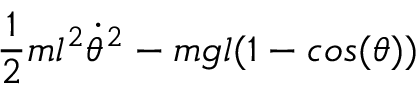Convert formula to latex. <formula><loc_0><loc_0><loc_500><loc_500>\frac { 1 } { 2 } m l ^ { 2 } \dot { \theta } ^ { 2 } - m g l ( 1 - \cos ( \theta ) )</formula> 